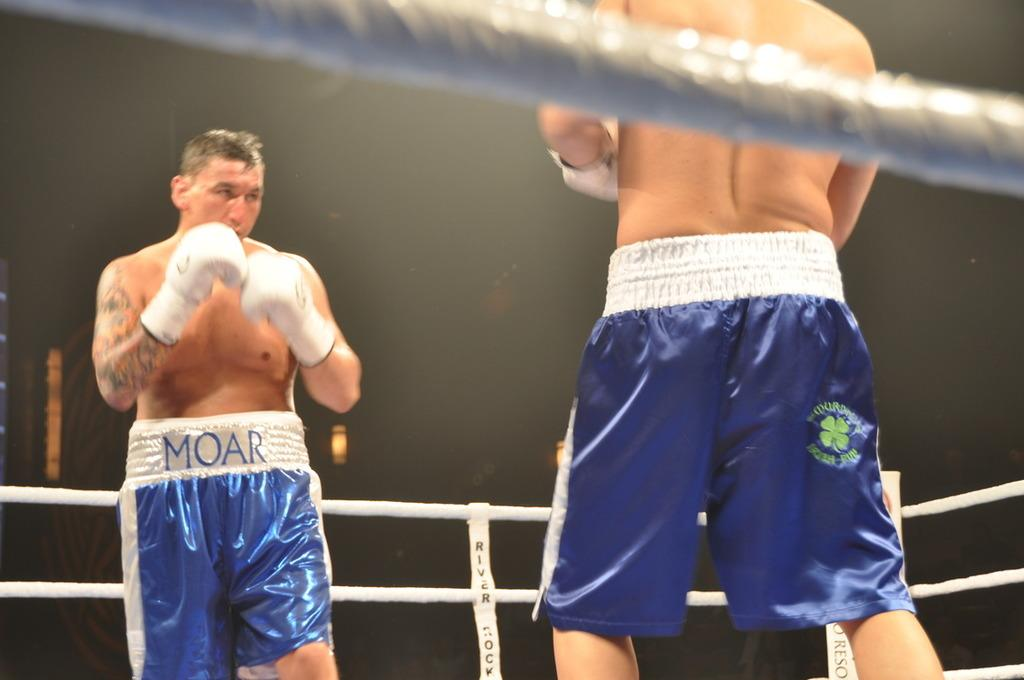<image>
Share a concise interpretation of the image provided. Two boxers in blue and white shors with the word moar on his waist band. 